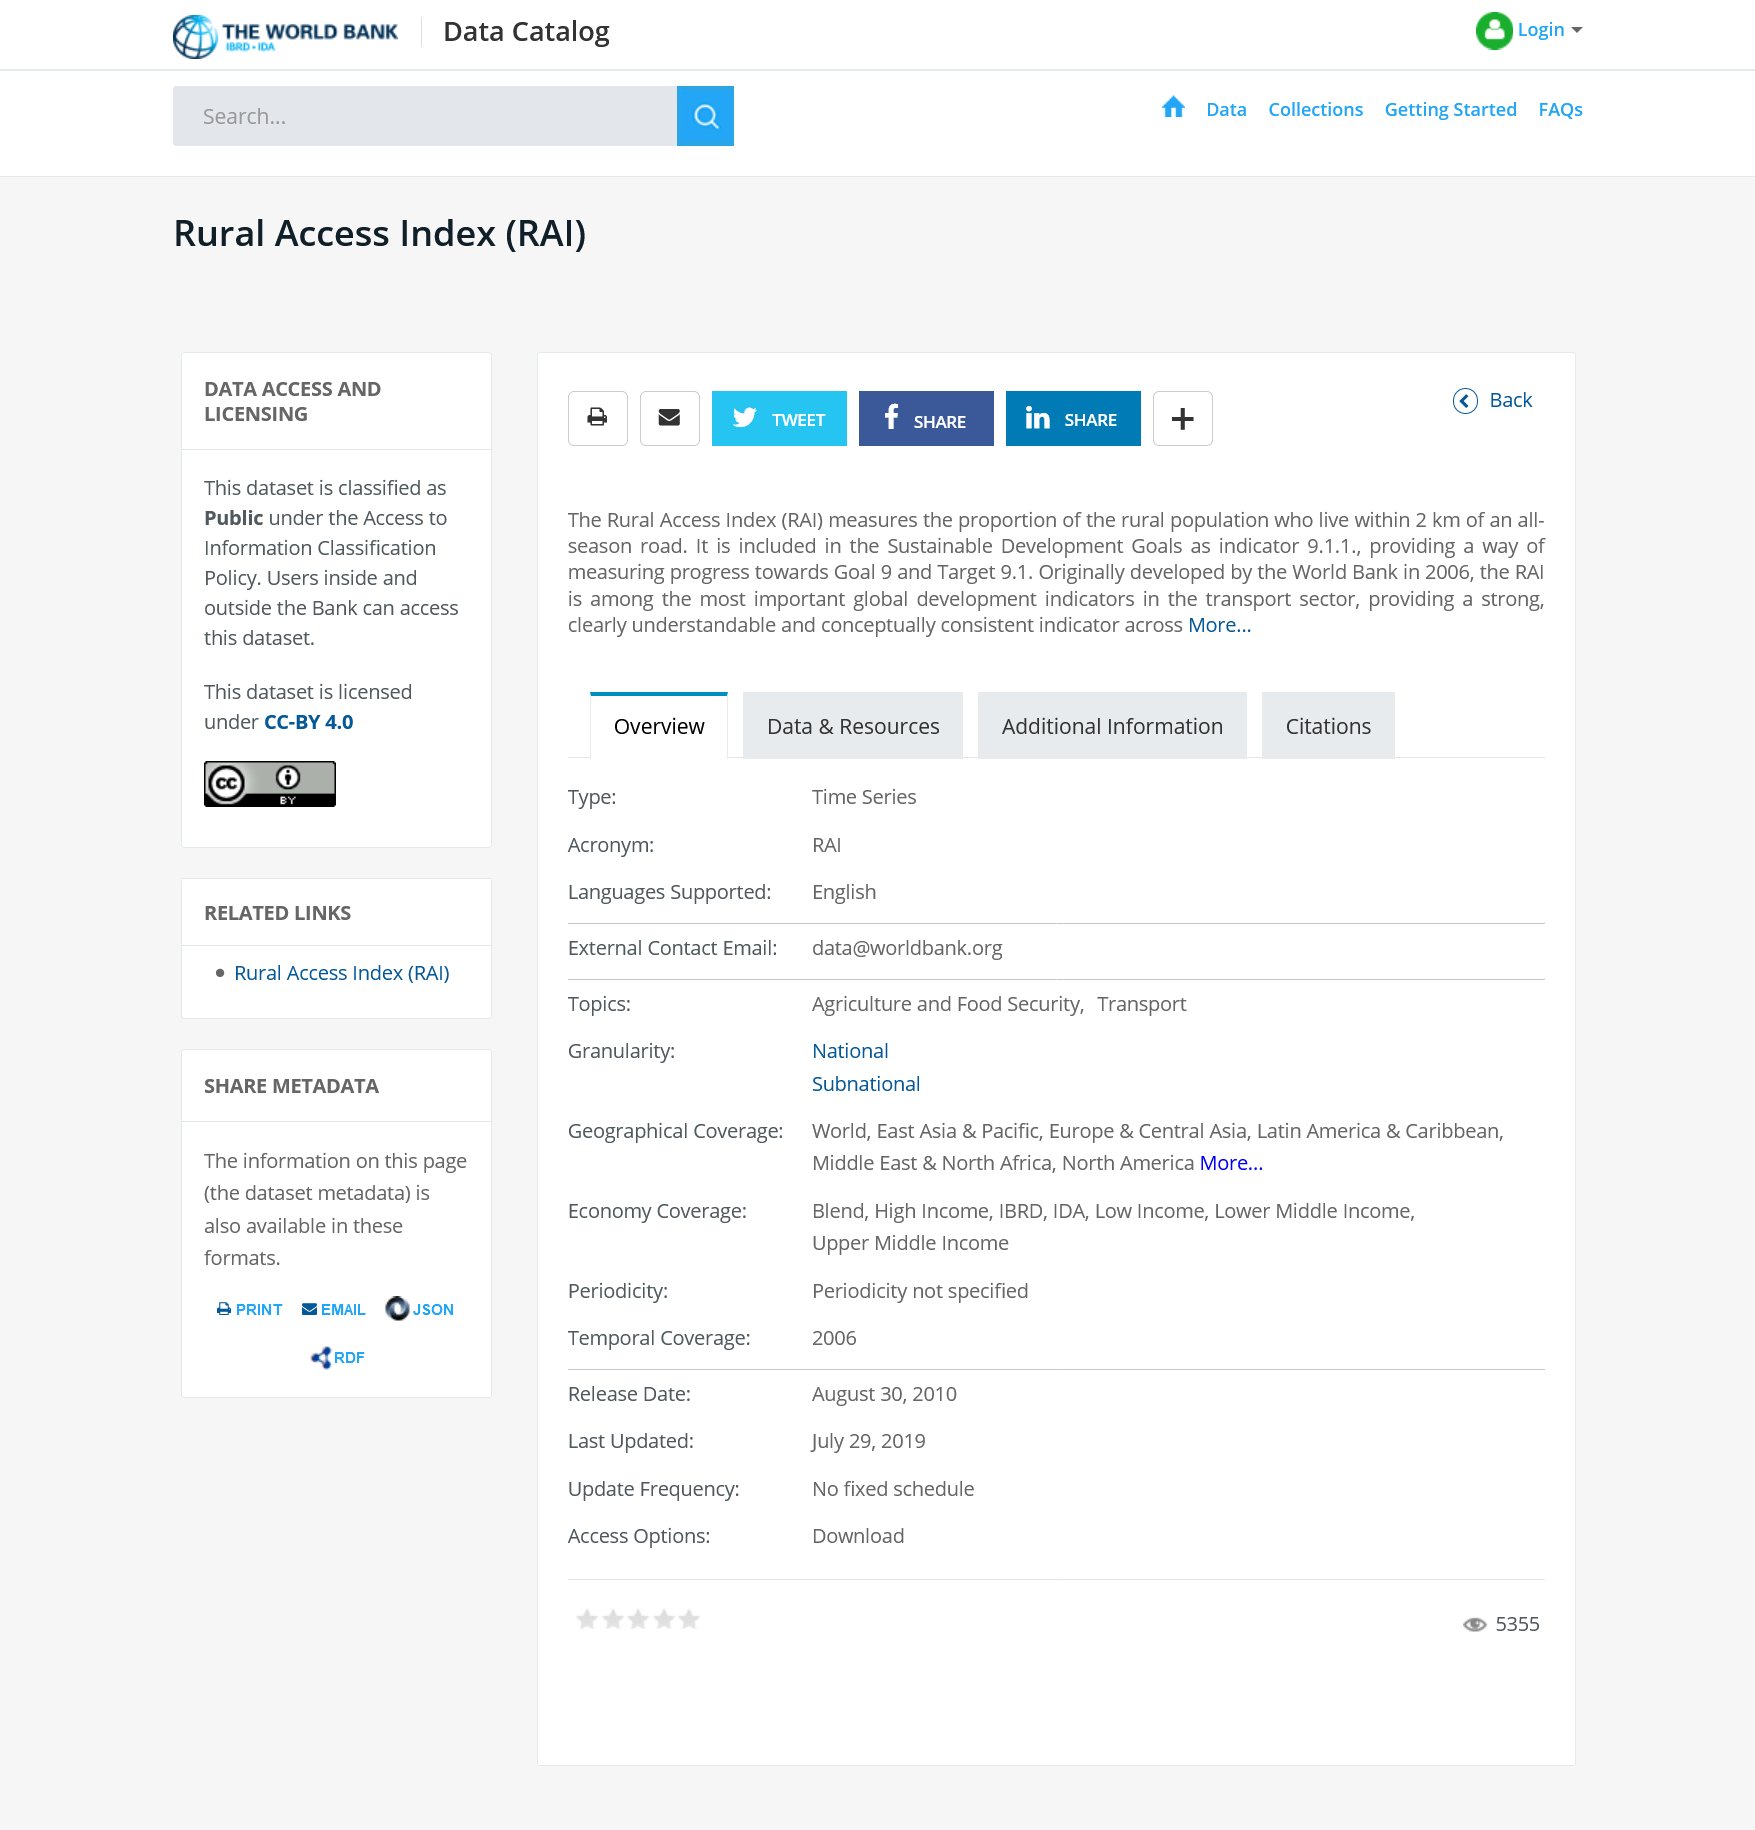Point out several critical features in this image. The dataset is considered public under the Access to Information Classification Policy. This page is about the Rural Access Index and its purpose. Yes, I can confirm that this share is compatible with Facebook. 